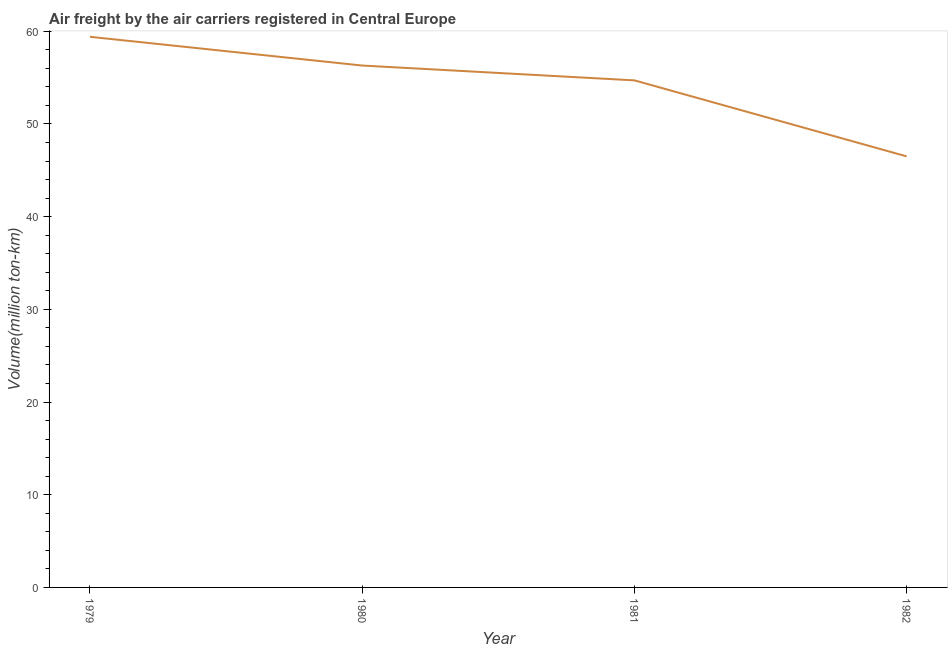What is the air freight in 1980?
Your answer should be compact. 56.3. Across all years, what is the maximum air freight?
Your answer should be very brief. 59.4. Across all years, what is the minimum air freight?
Give a very brief answer. 46.5. In which year was the air freight maximum?
Provide a short and direct response. 1979. What is the sum of the air freight?
Provide a succinct answer. 216.9. What is the difference between the air freight in 1979 and 1980?
Your answer should be very brief. 3.1. What is the average air freight per year?
Make the answer very short. 54.23. What is the median air freight?
Your answer should be very brief. 55.5. What is the ratio of the air freight in 1980 to that in 1981?
Give a very brief answer. 1.03. Is the air freight in 1979 less than that in 1981?
Provide a succinct answer. No. Is the difference between the air freight in 1979 and 1981 greater than the difference between any two years?
Provide a succinct answer. No. What is the difference between the highest and the second highest air freight?
Give a very brief answer. 3.1. What is the difference between the highest and the lowest air freight?
Give a very brief answer. 12.9. Does the air freight monotonically increase over the years?
Ensure brevity in your answer.  No. How many lines are there?
Provide a succinct answer. 1. Does the graph contain any zero values?
Ensure brevity in your answer.  No. Does the graph contain grids?
Give a very brief answer. No. What is the title of the graph?
Give a very brief answer. Air freight by the air carriers registered in Central Europe. What is the label or title of the Y-axis?
Give a very brief answer. Volume(million ton-km). What is the Volume(million ton-km) of 1979?
Make the answer very short. 59.4. What is the Volume(million ton-km) in 1980?
Your answer should be compact. 56.3. What is the Volume(million ton-km) in 1981?
Your answer should be very brief. 54.7. What is the Volume(million ton-km) of 1982?
Your answer should be very brief. 46.5. What is the difference between the Volume(million ton-km) in 1979 and 1980?
Give a very brief answer. 3.1. What is the ratio of the Volume(million ton-km) in 1979 to that in 1980?
Your answer should be compact. 1.05. What is the ratio of the Volume(million ton-km) in 1979 to that in 1981?
Your answer should be very brief. 1.09. What is the ratio of the Volume(million ton-km) in 1979 to that in 1982?
Offer a terse response. 1.28. What is the ratio of the Volume(million ton-km) in 1980 to that in 1982?
Your answer should be very brief. 1.21. What is the ratio of the Volume(million ton-km) in 1981 to that in 1982?
Provide a succinct answer. 1.18. 